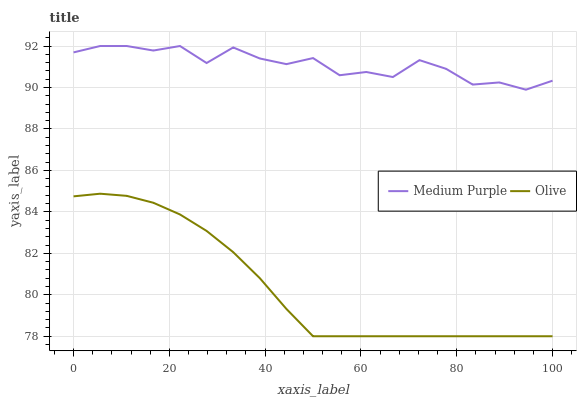Does Olive have the minimum area under the curve?
Answer yes or no. Yes. Does Medium Purple have the maximum area under the curve?
Answer yes or no. Yes. Does Olive have the maximum area under the curve?
Answer yes or no. No. Is Olive the smoothest?
Answer yes or no. Yes. Is Medium Purple the roughest?
Answer yes or no. Yes. Is Olive the roughest?
Answer yes or no. No. Does Olive have the lowest value?
Answer yes or no. Yes. Does Medium Purple have the highest value?
Answer yes or no. Yes. Does Olive have the highest value?
Answer yes or no. No. Is Olive less than Medium Purple?
Answer yes or no. Yes. Is Medium Purple greater than Olive?
Answer yes or no. Yes. Does Olive intersect Medium Purple?
Answer yes or no. No. 